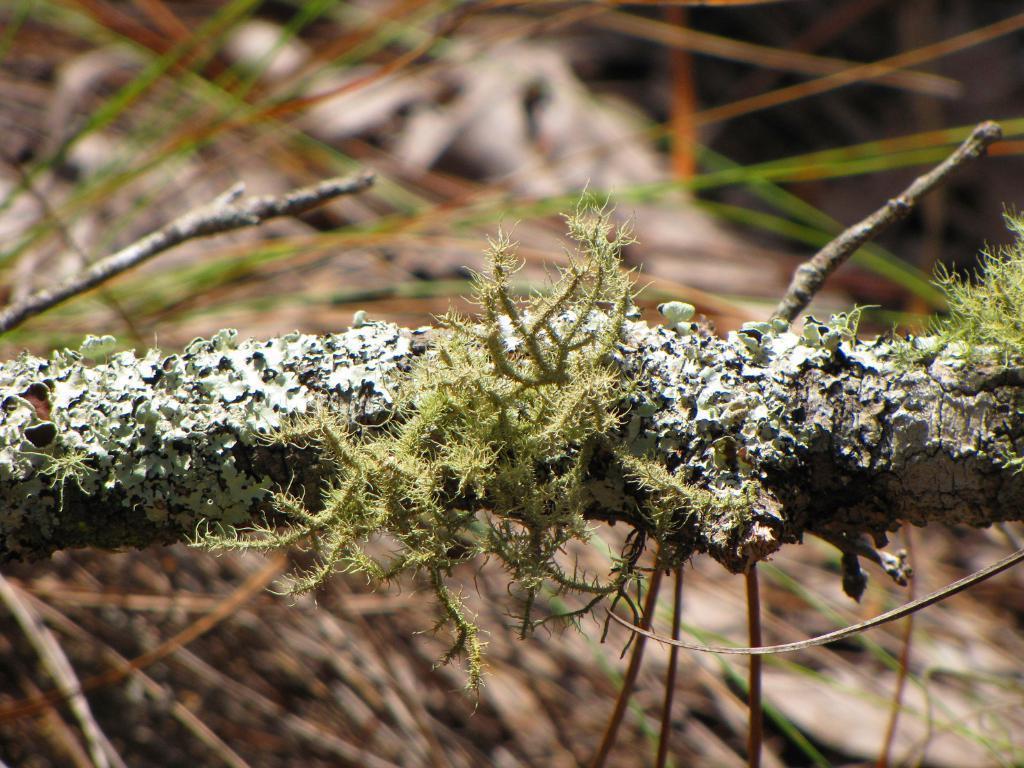In one or two sentences, can you explain what this image depicts? In this image we can see a branch of a tree with some algae. 